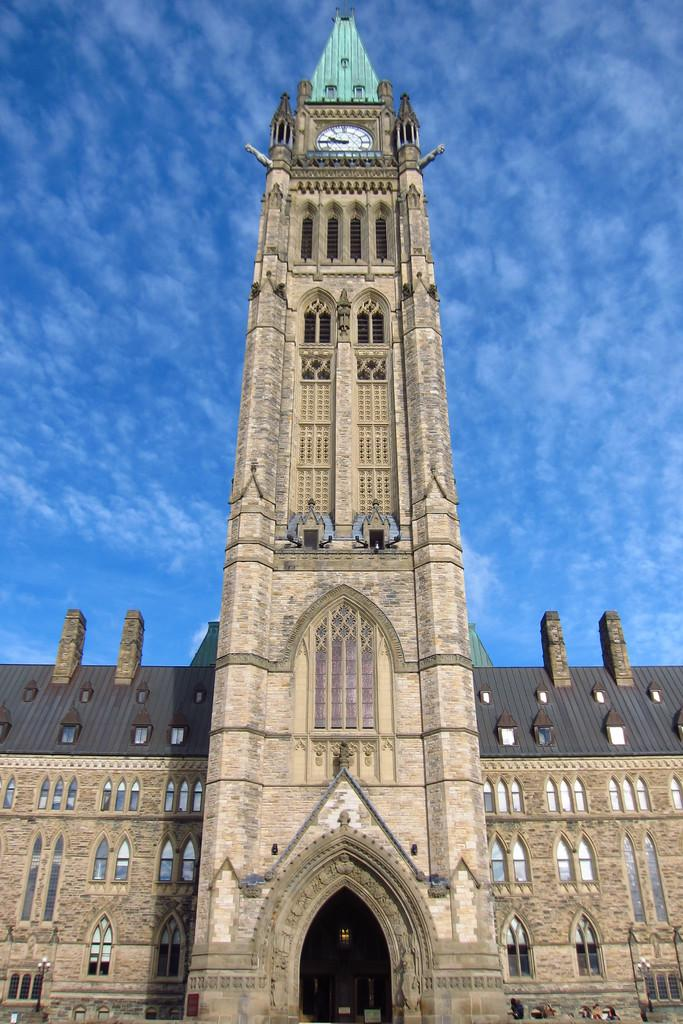What is the main structure in the image? There is a building in the image. What feature can be seen on the building? The building has windows. What can be observed in the sky in the image? There are clouds visible in the sky. What is the color of the sky in the image? The sky is blue in color. Where is the advertisement for the bedroom located in the image? There is no advertisement or bedroom present in the image. How does the dust affect the appearance of the building in the image? There is no dust present in the image, so it does not affect the appearance of the building. 